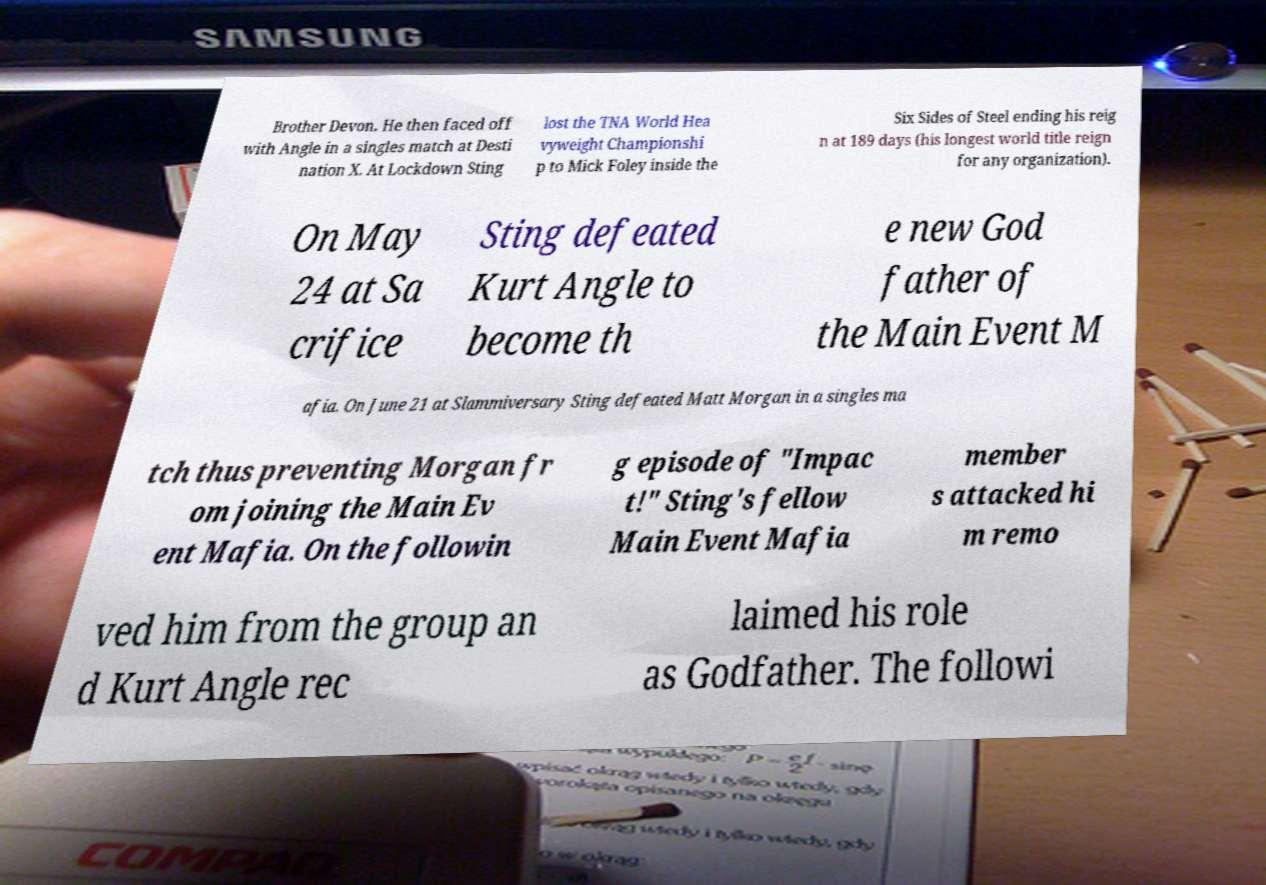Could you assist in decoding the text presented in this image and type it out clearly? Brother Devon. He then faced off with Angle in a singles match at Desti nation X. At Lockdown Sting lost the TNA World Hea vyweight Championshi p to Mick Foley inside the Six Sides of Steel ending his reig n at 189 days (his longest world title reign for any organization). On May 24 at Sa crifice Sting defeated Kurt Angle to become th e new God father of the Main Event M afia. On June 21 at Slammiversary Sting defeated Matt Morgan in a singles ma tch thus preventing Morgan fr om joining the Main Ev ent Mafia. On the followin g episode of "Impac t!" Sting's fellow Main Event Mafia member s attacked hi m remo ved him from the group an d Kurt Angle rec laimed his role as Godfather. The followi 